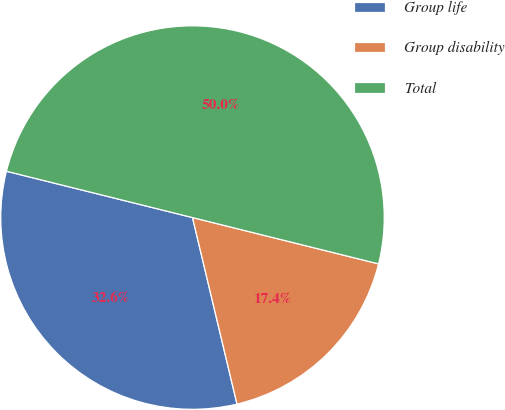Convert chart. <chart><loc_0><loc_0><loc_500><loc_500><pie_chart><fcel>Group life<fcel>Group disability<fcel>Total<nl><fcel>32.61%<fcel>17.39%<fcel>50.0%<nl></chart> 